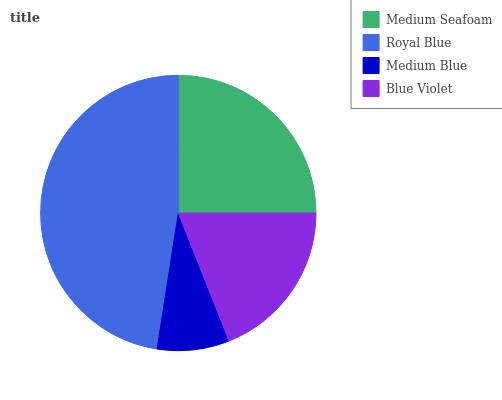Is Medium Blue the minimum?
Answer yes or no. Yes. Is Royal Blue the maximum?
Answer yes or no. Yes. Is Royal Blue the minimum?
Answer yes or no. No. Is Medium Blue the maximum?
Answer yes or no. No. Is Royal Blue greater than Medium Blue?
Answer yes or no. Yes. Is Medium Blue less than Royal Blue?
Answer yes or no. Yes. Is Medium Blue greater than Royal Blue?
Answer yes or no. No. Is Royal Blue less than Medium Blue?
Answer yes or no. No. Is Medium Seafoam the high median?
Answer yes or no. Yes. Is Blue Violet the low median?
Answer yes or no. Yes. Is Medium Blue the high median?
Answer yes or no. No. Is Medium Seafoam the low median?
Answer yes or no. No. 